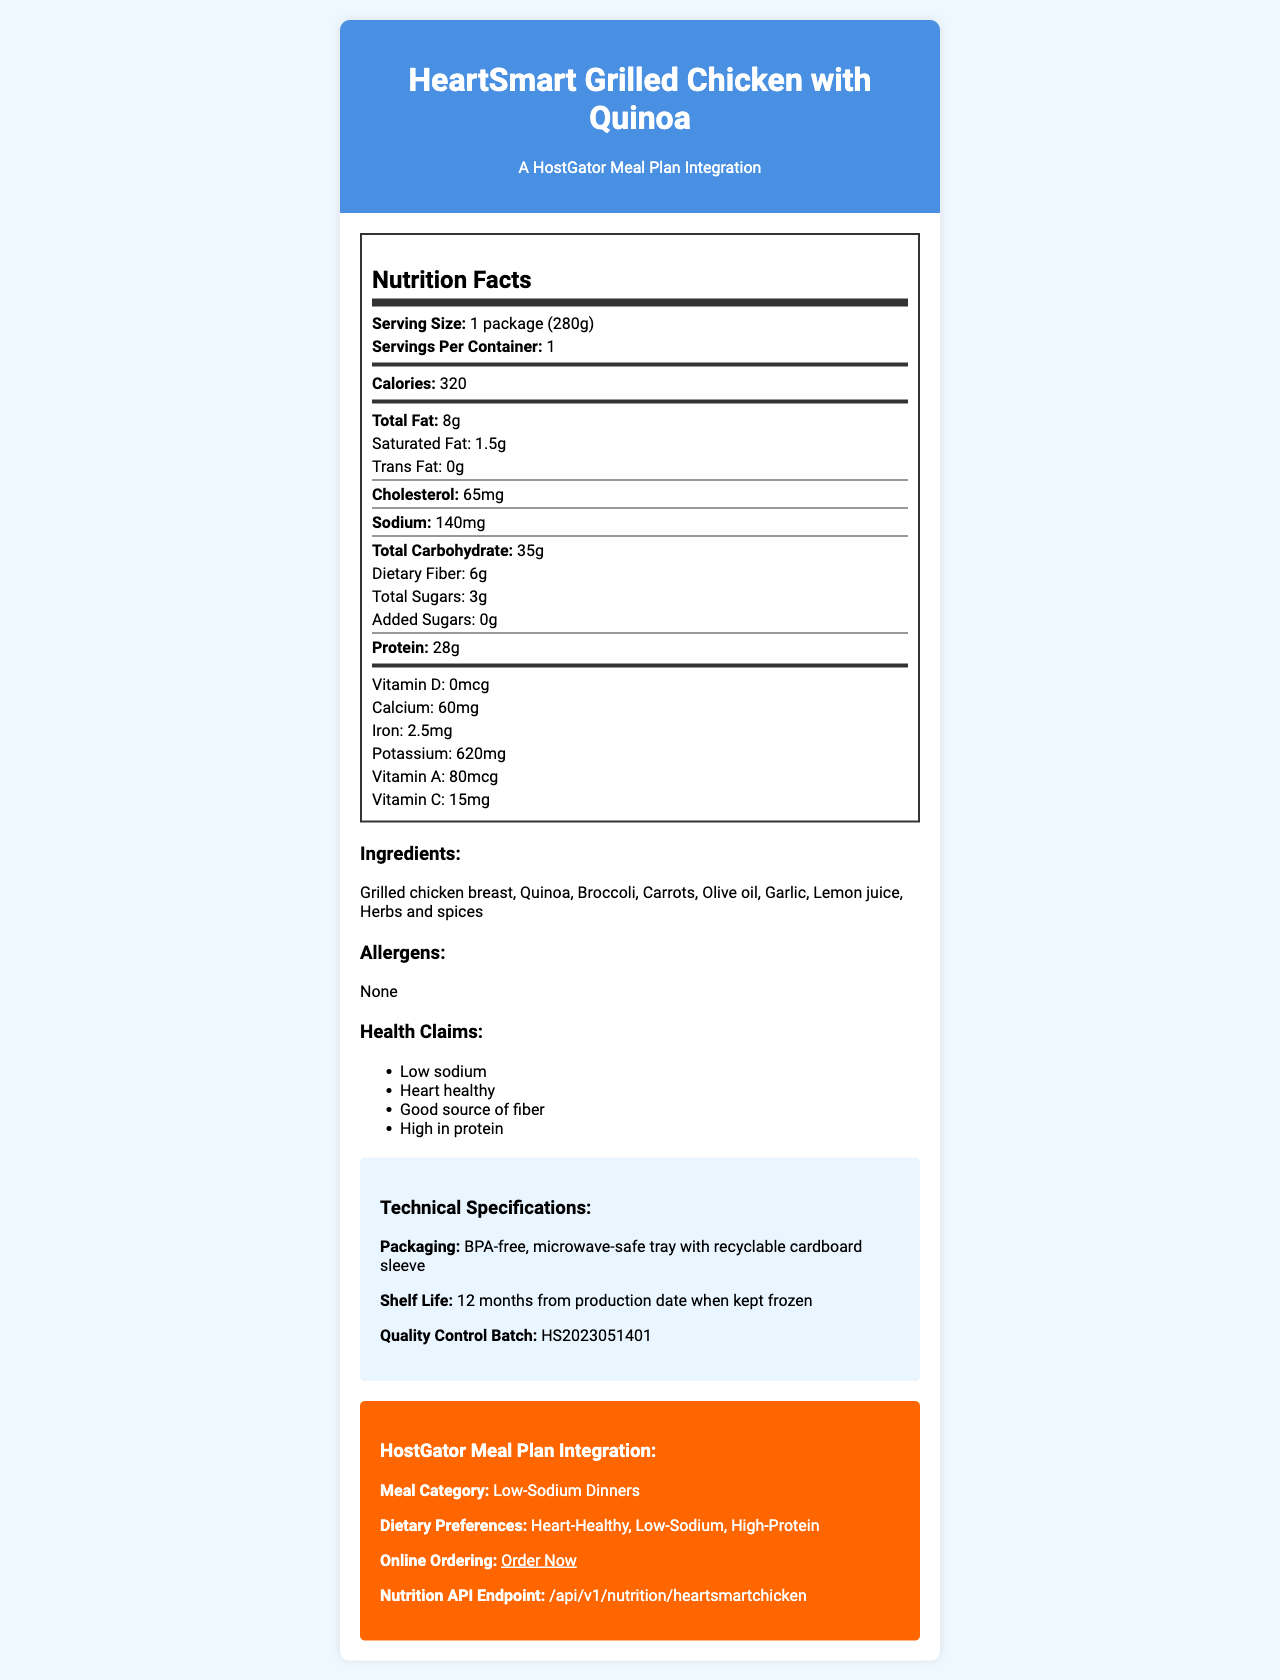how many servings are in one container? The document specifies that there is 1 serving per container.
Answer: 1 how much protein does one serving include? The document clearly states that one serving contains 28 grams of protein.
Answer: 28 grams which vitamins are listed in this document? The vitamins listed are specified under the nutrition labels section.
Answer: Vitamin D, Calcium, Iron, Potassium, Vitamin A, Vitamin C what is the serving size of the meal? The serving size mentioned in the document is 1 package, which weighs 280 grams.
Answer: 1 package (280g) is this meal low in sodium? The document claims that the meal is "Low sodium," and the sodium content is listed as 140mg, which aligns with a low-sodium requirement.
Answer: Yes what is the total fat content? A. 8g B. 10g C. 15g D. 20g According to the nutrition label, the total fat content is 8 grams.
Answer: A. 8g what is the cholesterol content in this product? The nutrition label on the document states that the cholesterol content is 65 milligrams.
Answer: 65mg which of the following is an ingredient? I. Quinoa II. Rice III. Pasta Among the listed ingredients, only Quinoa is present.
Answer: I. Quinoa does the product contain any allergens? The document lists allergens and specifies "None," indicating no allergens are present.
Answer: No what are the health claims made about this product? The health claims listed include low sodium, heart healthy, good source of fiber, and high in protein.
Answer: Low sodium, Heart healthy, Good source of fiber, High in protein summarize the main information of the document. The document provides essential information about the frozen meal, including nutritional values, ingredients, allergens, health benefits, preparation, storage, and ordering through HostGator's meal plan. Technical details about packaging and shelf life are also included.
Answer: The product is a "HeartSmart Grilled Chicken with Quinoa," a low-sodium, heart-healthy frozen meal. It contains various nutrients, with details about serving size, calories, fat, fiber, vitamins, and minerals. Ingredients and health claims are listed, along with preparation, storage instructions, and technical specifications. It integrates with the HostGator meal plan for easy online ordering. what is the quality control batch number? The batch number can be found under the technical specifications section.
Answer: HS2023051401 how long is the shelf life of this meal? According to the technical specifications, the shelf life is 12 months from the production date if the meal is kept frozen.
Answer: 12 months from the production date when kept frozen can you microwave the meal for 5 minutes? The preparation instructions state to microwave the meal for 3-4 minutes or until the internal temperature reaches 165°F (74°C), not for 5 minutes.
Answer: No how many calories does one serving provide? The calorie content of one serving is specified as 320.
Answer: 320 calories what is the added sugars content? The nutrition label shows that the added sugars content is 0 grams.
Answer: 0 grams how much calcium is in one serving? The nutrition label states that one serving contains 60 milligrams of calcium.
Answer: 60mg who is the manufacturer? The document lists the manufacturer as HealthyChoice Foods, Inc.
Answer: HealthyChoice Foods, Inc. how can someone contact customer service for this product? The customer service number provided in the document is 1-800-555-HEAL.
Answer: 1-800-555-HEAL where can you find more information or order the product online? The online ordering link provided is https://www.hostgator.com/mealplanner/heartsmartchicken.
Answer: https://www.hostgator.com/mealplanner/heartsmartchicken what is the production date? The document doesn't provide any information or a date related to the production date.
Answer: Cannot be determined 